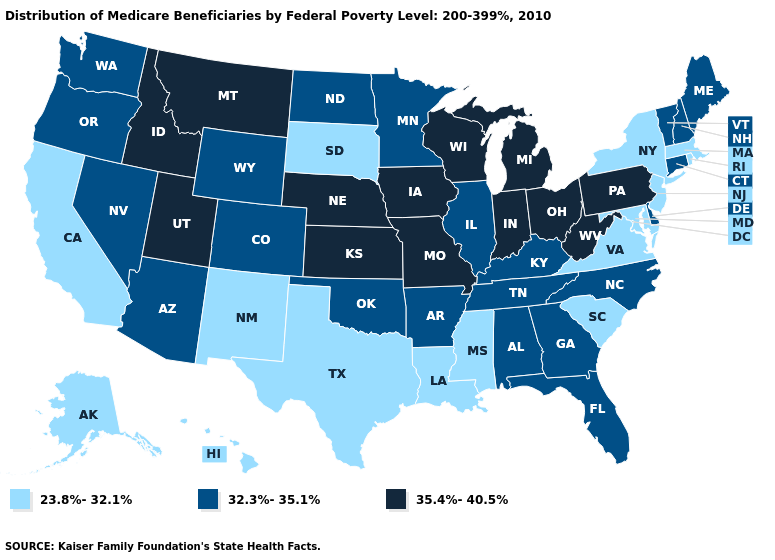Among the states that border Illinois , does Kentucky have the highest value?
Give a very brief answer. No. Does Illinois have the highest value in the USA?
Give a very brief answer. No. What is the lowest value in the USA?
Concise answer only. 23.8%-32.1%. What is the lowest value in states that border Iowa?
Concise answer only. 23.8%-32.1%. Among the states that border Minnesota , does South Dakota have the lowest value?
Quick response, please. Yes. Among the states that border South Carolina , which have the highest value?
Quick response, please. Georgia, North Carolina. Does Pennsylvania have the highest value in the Northeast?
Give a very brief answer. Yes. What is the value of Iowa?
Answer briefly. 35.4%-40.5%. What is the highest value in states that border Kentucky?
Write a very short answer. 35.4%-40.5%. Does Minnesota have the highest value in the MidWest?
Quick response, please. No. What is the value of South Carolina?
Quick response, please. 23.8%-32.1%. Is the legend a continuous bar?
Write a very short answer. No. Name the states that have a value in the range 32.3%-35.1%?
Write a very short answer. Alabama, Arizona, Arkansas, Colorado, Connecticut, Delaware, Florida, Georgia, Illinois, Kentucky, Maine, Minnesota, Nevada, New Hampshire, North Carolina, North Dakota, Oklahoma, Oregon, Tennessee, Vermont, Washington, Wyoming. Name the states that have a value in the range 23.8%-32.1%?
Be succinct. Alaska, California, Hawaii, Louisiana, Maryland, Massachusetts, Mississippi, New Jersey, New Mexico, New York, Rhode Island, South Carolina, South Dakota, Texas, Virginia. Which states have the lowest value in the West?
Concise answer only. Alaska, California, Hawaii, New Mexico. 